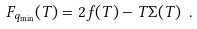<formula> <loc_0><loc_0><loc_500><loc_500>F _ { q _ { \min } } ( T ) = 2 f ( T ) - T \Sigma ( T ) \ .</formula> 